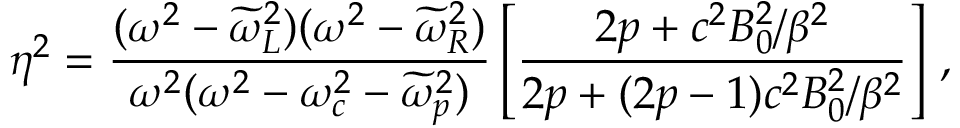<formula> <loc_0><loc_0><loc_500><loc_500>\eta ^ { 2 } = \frac { ( \omega ^ { 2 } - \widetilde { \omega } _ { L } ^ { 2 } ) ( \omega ^ { 2 } - \widetilde { \omega } _ { R } ^ { 2 } ) } { \omega ^ { 2 } ( \omega ^ { 2 } - \omega _ { c } ^ { 2 } - \widetilde { \omega } _ { p } ^ { 2 } ) } \left [ \frac { 2 p + c ^ { 2 } B _ { 0 } ^ { 2 } / \beta ^ { 2 } } { 2 p + ( 2 p - 1 ) c ^ { 2 } B _ { 0 } ^ { 2 } / \beta ^ { 2 } } \right ] \, ,</formula> 